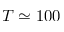Convert formula to latex. <formula><loc_0><loc_0><loc_500><loc_500>T \simeq 1 0 0</formula> 